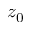<formula> <loc_0><loc_0><loc_500><loc_500>z _ { 0 }</formula> 